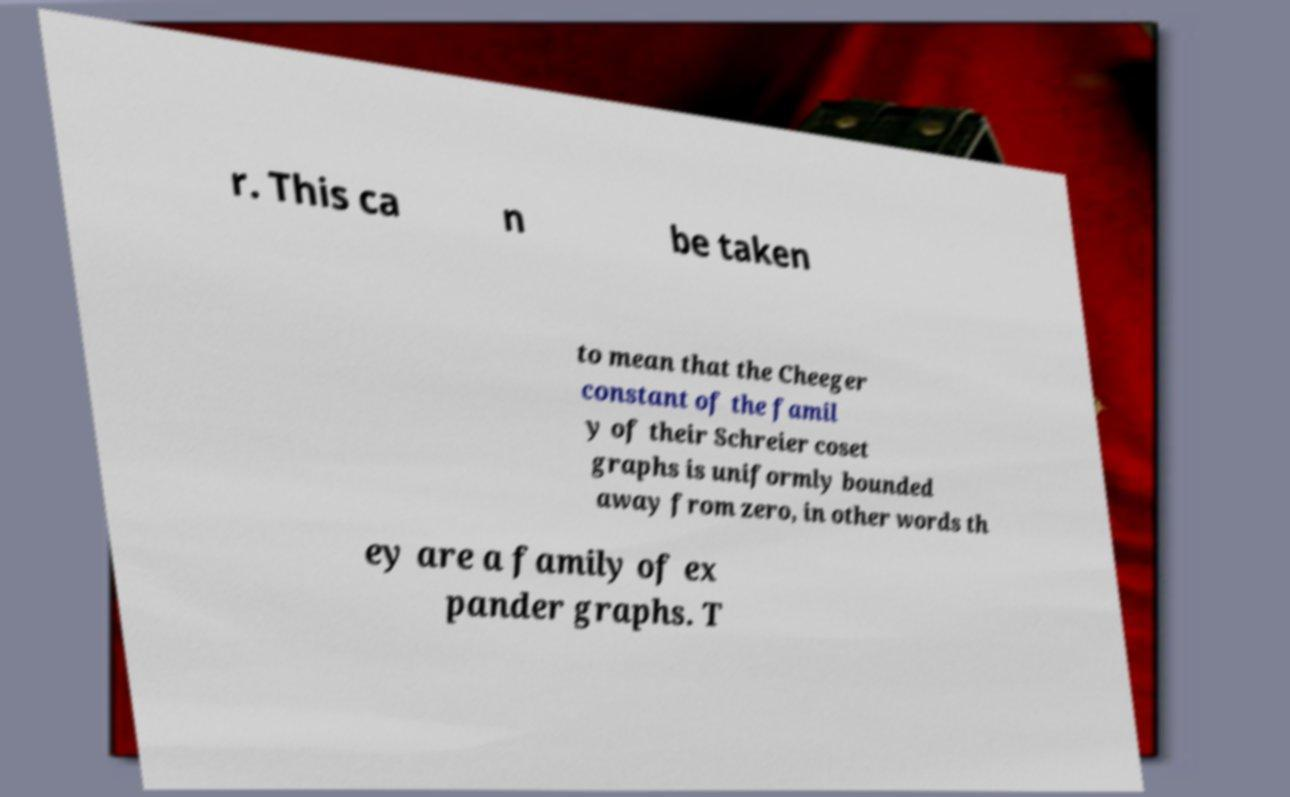For documentation purposes, I need the text within this image transcribed. Could you provide that? r. This ca n be taken to mean that the Cheeger constant of the famil y of their Schreier coset graphs is uniformly bounded away from zero, in other words th ey are a family of ex pander graphs. T 